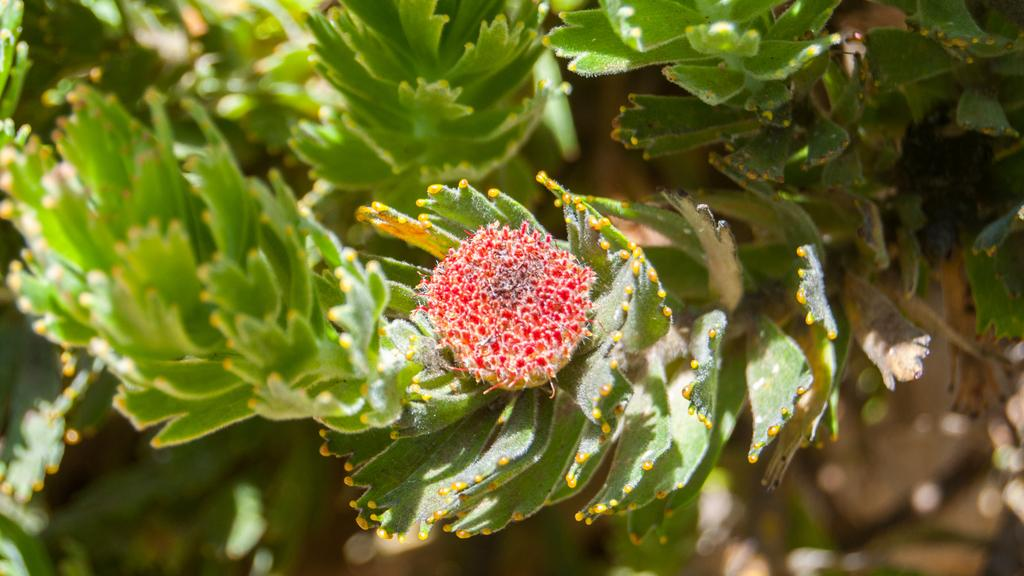What is the main subject of the image? There is a small flower in the middle of the image. What can be seen in the background of the image? There are green leaves in the background of the image. How many points does the flower have on its body in the image? The flower does not have points on its body, and the concept of points is not applicable to flowers. 